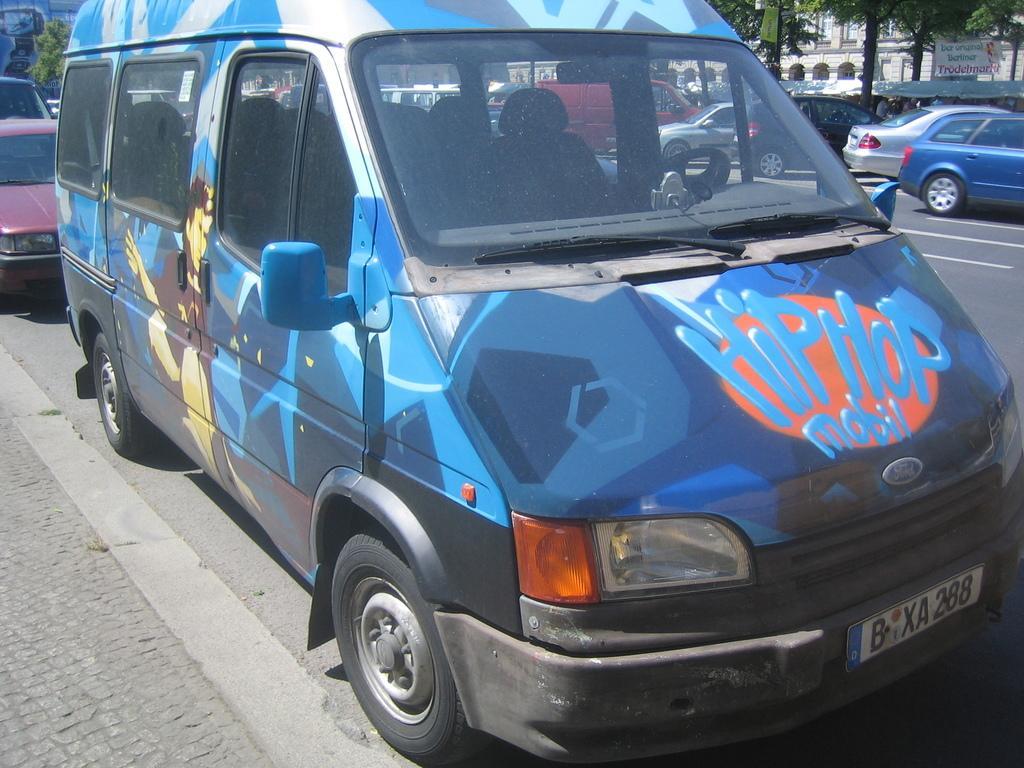Could you give a brief overview of what you see in this image? In the picture I can see vehicles on the road. In the background I can see trees, buildings and some other objects. The vehicle in the front is blue in color and something written on it. 